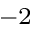<formula> <loc_0><loc_0><loc_500><loc_500>^ { - 2 }</formula> 